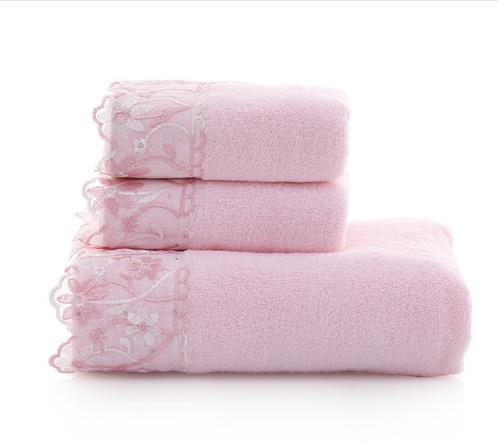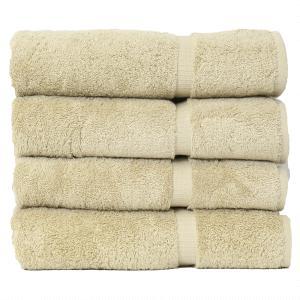The first image is the image on the left, the second image is the image on the right. Given the left and right images, does the statement "Each image contains different towel sizes, and at least one image shows at least three different towel sizes in one stack." hold true? Answer yes or no. No. The first image is the image on the left, the second image is the image on the right. Given the left and right images, does the statement "There are 4 bath-towels of equal size stacked on top of each other" hold true? Answer yes or no. Yes. 